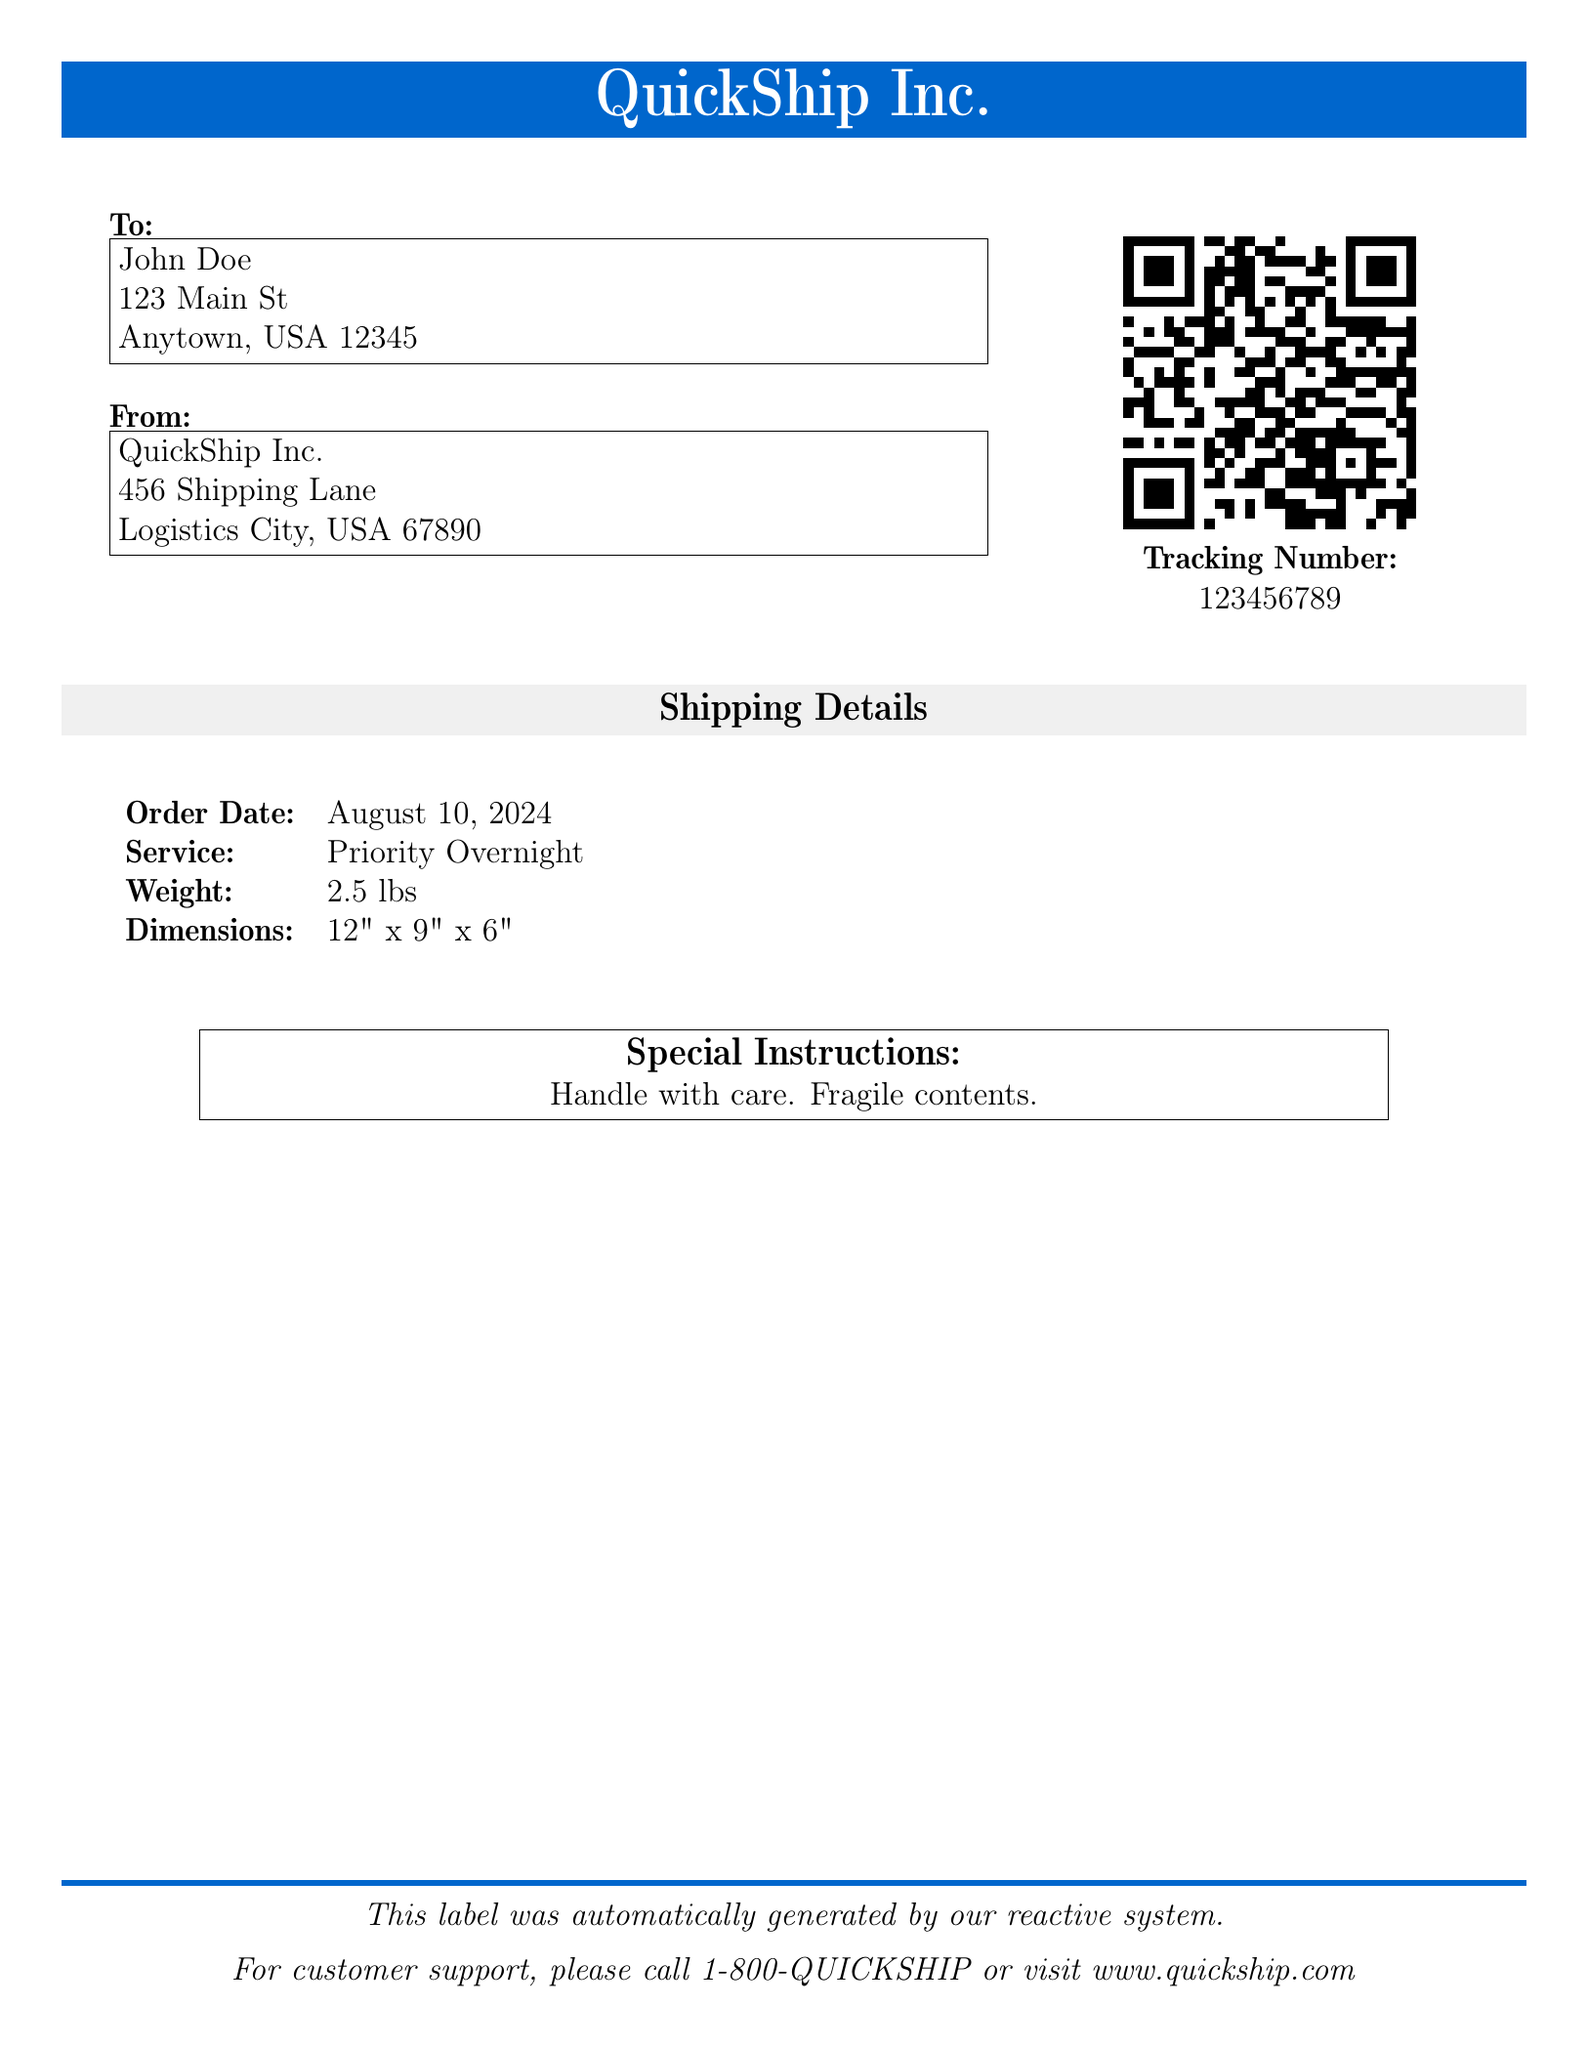What is the recipient's name? The recipient's name is listed at the top under "To".
Answer: John Doe What is the shipping company's name? The shipping company's name is shown prominently at the top of the document.
Answer: QuickShip Inc What is the tracking number? The tracking number is displayed below the QR code.
Answer: 123456789 What is the order date? The order date is mentioned in the shipping details section, indicated by the command for today's date.
Answer: Today's date What are the dimensions of the package? The dimensions are specified in the shipping details section.
Answer: 12" x 9" x 6" What special instructions are given? The special instructions are provided in a labeled box towards the bottom.
Answer: Handle with care. Fragile contents What is the shipping service used? The shipping service is indicated in the shipping details section.
Answer: Priority Overnight What is the weight of the package? The weight is noted in the shipping details of the document.
Answer: 2.5 lbs What is the phone number for customer support? The customer support phone number is mentioned at the bottom of the document.
Answer: 1-800-QUICKSHIP 